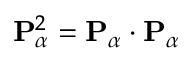<formula> <loc_0><loc_0><loc_500><loc_500>{ P } _ { \alpha } ^ { 2 } = { P } _ { \alpha } \cdot { P } _ { \alpha }</formula> 